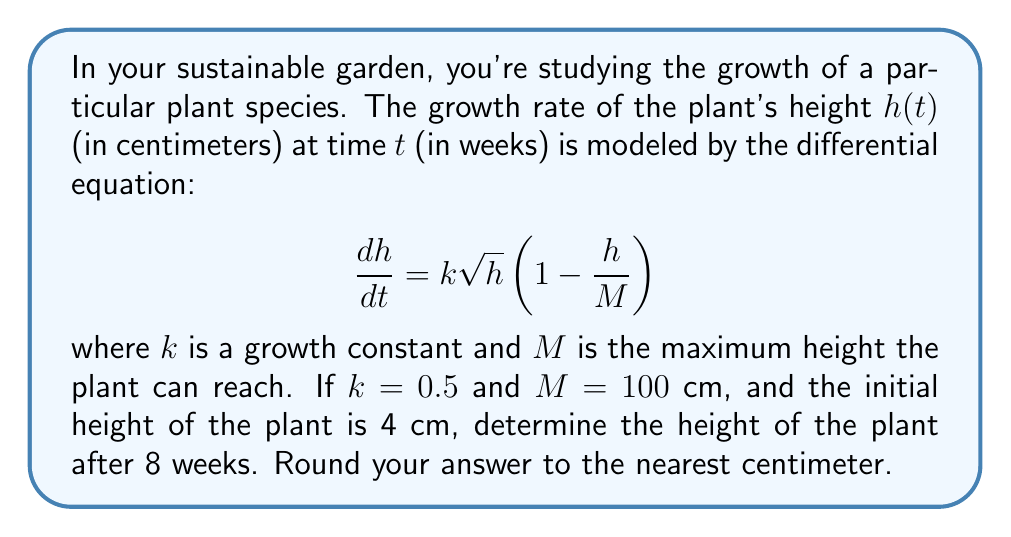Can you answer this question? To solve this problem, we need to use functional analysis and differential equations. Let's approach this step-by-step:

1) First, we have the differential equation:

   $$\frac{dh}{dt} = k\sqrt{h}(1 - \frac{h}{M})$$

2) We're given that $k = 0.5$, $M = 100$, and the initial condition $h(0) = 4$. Let's substitute these values:

   $$\frac{dh}{dt} = 0.5\sqrt{h}(1 - \frac{h}{100})$$

3) This is a separable differential equation. Let's separate the variables:

   $$\frac{dh}{\sqrt{h}(1 - \frac{h}{100})} = 0.5dt$$

4) Integrating both sides:

   $$\int \frac{dh}{\sqrt{h}(1 - \frac{h}{100})} = \int 0.5dt$$

5) The left side of this equation is a complex integral. The solution to this integral is:

   $$2\sqrt{100}\tanh^{-1}(\frac{\sqrt{h}}{10}) = 0.5t + C$$

   where $C$ is a constant of integration.

6) Using the initial condition $h(0) = 4$, we can find $C$:

   $$20\tanh^{-1}(\frac{2}{10}) = C$$
   $$C \approx 4.0547$$

7) Now our equation is:

   $$20\tanh^{-1}(\frac{\sqrt{h}}{10}) = 0.5t + 4.0547$$

8) To find $h$ after 8 weeks, we substitute $t = 8$:

   $$20\tanh^{-1}(\frac{\sqrt{h}}{10}) = 0.5(8) + 4.0547$$
   $$20\tanh^{-1}(\frac{\sqrt{h}}{10}) = 8.0547$$

9) Solving for $h$:

   $$\tanh^{-1}(\frac{\sqrt{h}}{10}) = 0.40274$$
   $$\frac{\sqrt{h}}{10} = \tanh(0.40274)$$
   $$\sqrt{h} = 10\tanh(0.40274)$$
   $$h = 100\tanh^2(0.40274)$$

10) Calculating this value:

    $$h \approx 14.76 \text{ cm}$$

11) Rounding to the nearest centimeter:

    $$h \approx 15 \text{ cm}$$
Answer: 15 cm 